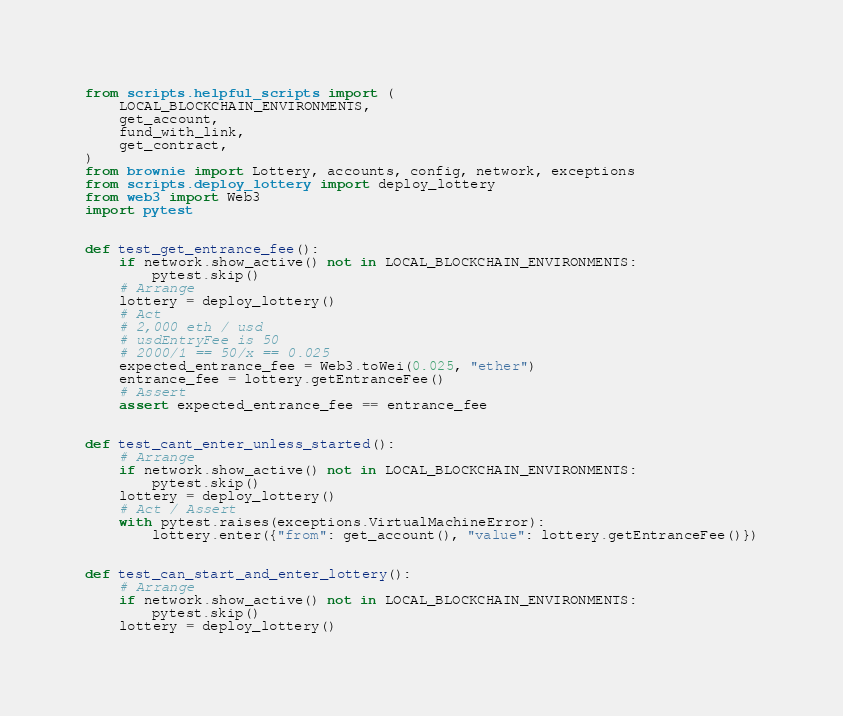<code> <loc_0><loc_0><loc_500><loc_500><_Python_>from scripts.helpful_scripts import (
    LOCAL_BLOCKCHAIN_ENVIRONMENTS,
    get_account,
    fund_with_link,
    get_contract,
)
from brownie import Lottery, accounts, config, network, exceptions
from scripts.deploy_lottery import deploy_lottery
from web3 import Web3
import pytest


def test_get_entrance_fee():
    if network.show_active() not in LOCAL_BLOCKCHAIN_ENVIRONMENTS:
        pytest.skip()
    # Arrange
    lottery = deploy_lottery()
    # Act
    # 2,000 eth / usd
    # usdEntryFee is 50
    # 2000/1 == 50/x == 0.025
    expected_entrance_fee = Web3.toWei(0.025, "ether")
    entrance_fee = lottery.getEntranceFee()
    # Assert
    assert expected_entrance_fee == entrance_fee


def test_cant_enter_unless_started():
    # Arrange
    if network.show_active() not in LOCAL_BLOCKCHAIN_ENVIRONMENTS:
        pytest.skip()
    lottery = deploy_lottery()
    # Act / Assert
    with pytest.raises(exceptions.VirtualMachineError):
        lottery.enter({"from": get_account(), "value": lottery.getEntranceFee()})


def test_can_start_and_enter_lottery():
    # Arrange
    if network.show_active() not in LOCAL_BLOCKCHAIN_ENVIRONMENTS:
        pytest.skip()
    lottery = deploy_lottery()</code> 